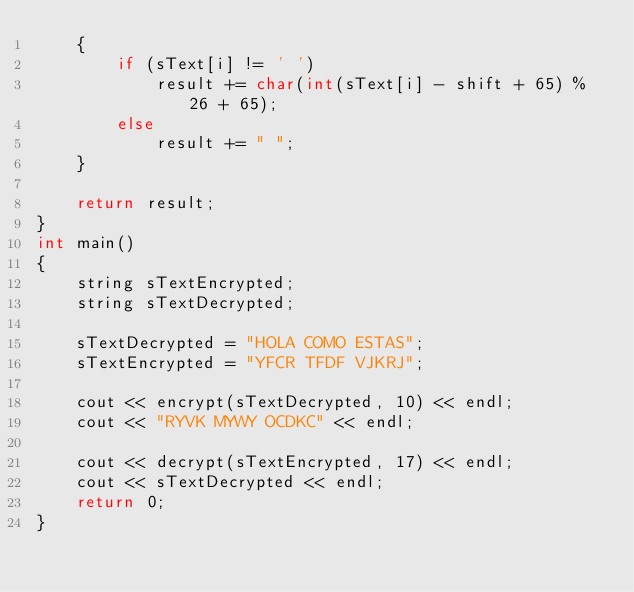<code> <loc_0><loc_0><loc_500><loc_500><_C++_>    {
        if (sText[i] != ' ')
            result += char(int(sText[i] - shift + 65) % 26 + 65);
        else
            result += " ";
    }

    return result;
}
int main()
{
    string sTextEncrypted;
    string sTextDecrypted;

    sTextDecrypted = "HOLA COMO ESTAS";
    sTextEncrypted = "YFCR TFDF VJKRJ";

    cout << encrypt(sTextDecrypted, 10) << endl;
    cout << "RYVK MYWY OCDKC" << endl;

    cout << decrypt(sTextEncrypted, 17) << endl;
    cout << sTextDecrypted << endl;
    return 0;
}</code> 